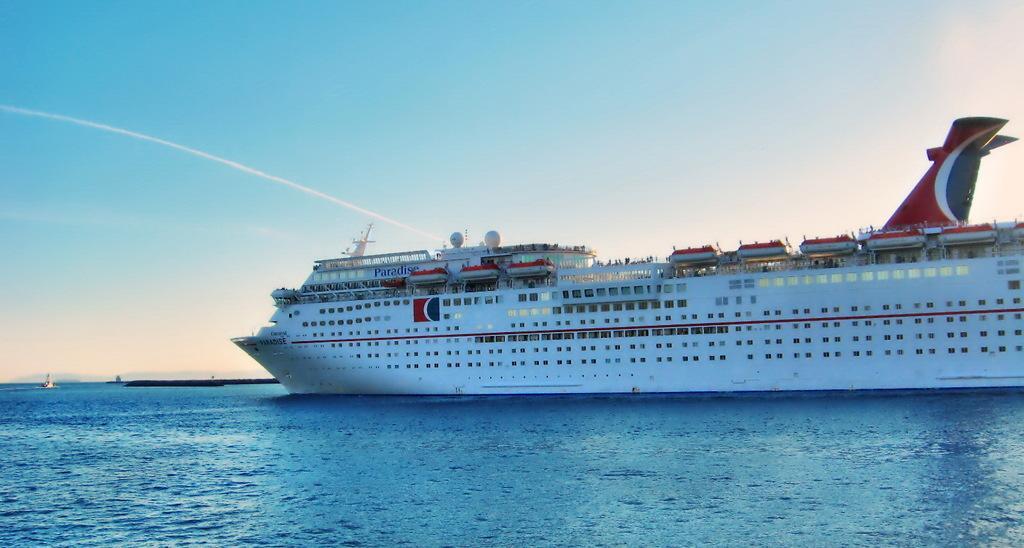Describe this image in one or two sentences. At the bottom there is water, this is a very big ship in white color. At the top it is the blue color sky. 